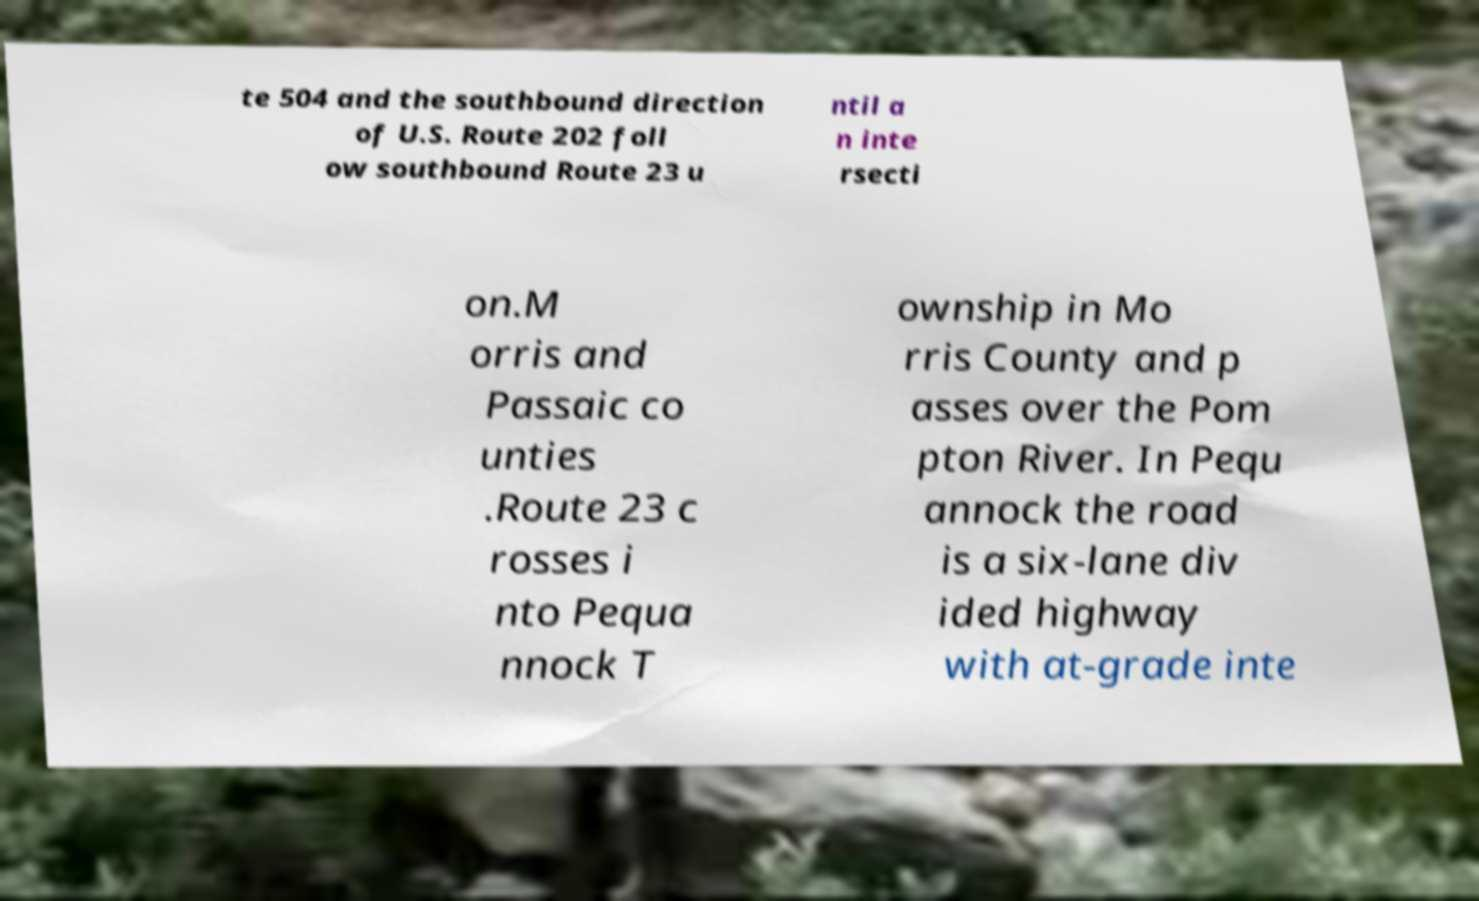I need the written content from this picture converted into text. Can you do that? te 504 and the southbound direction of U.S. Route 202 foll ow southbound Route 23 u ntil a n inte rsecti on.M orris and Passaic co unties .Route 23 c rosses i nto Pequa nnock T ownship in Mo rris County and p asses over the Pom pton River. In Pequ annock the road is a six-lane div ided highway with at-grade inte 